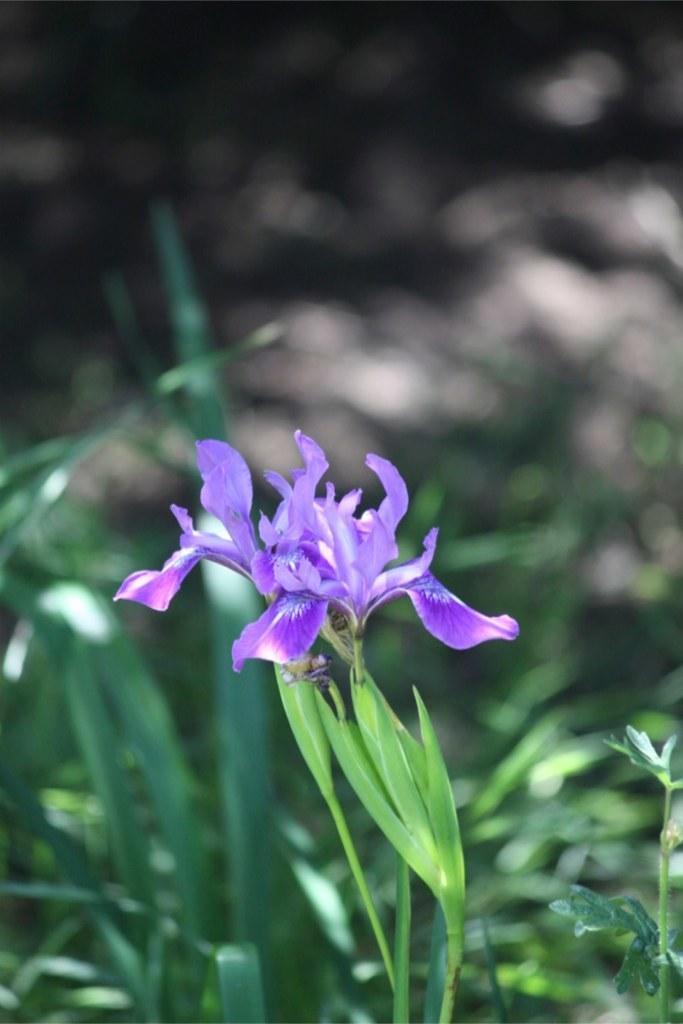How would you summarize this image in a sentence or two? In the image there are two purple color plants on a plant. In the background there are plants. The background is blurry. 